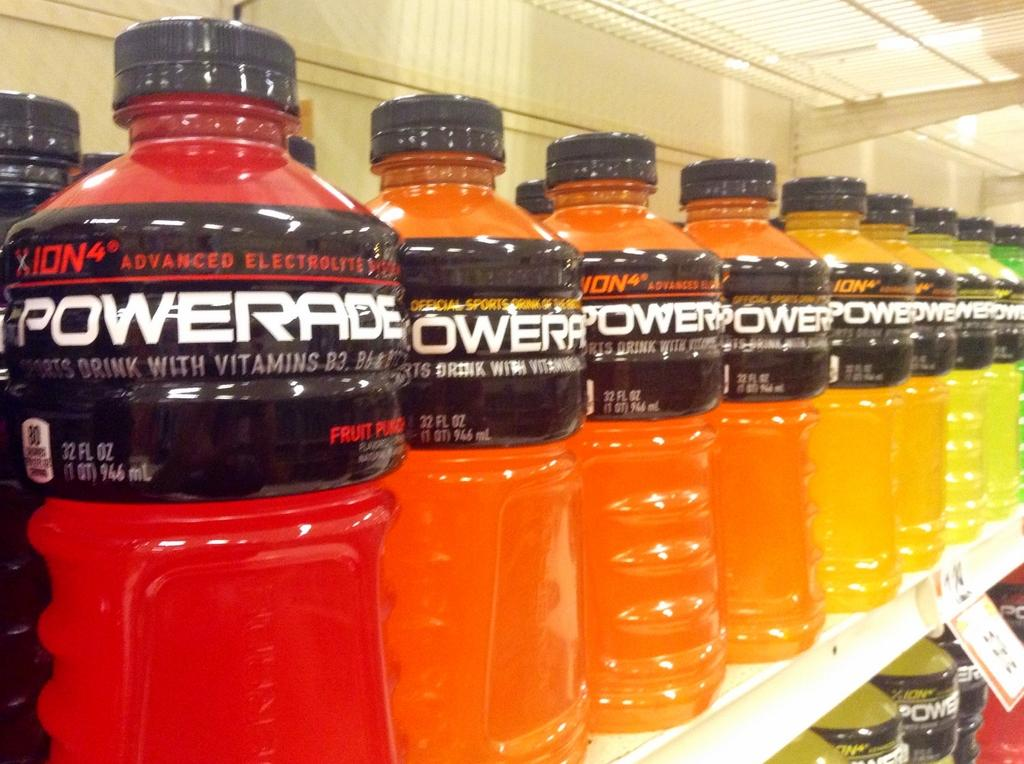<image>
Give a short and clear explanation of the subsequent image. Bottles of Powerade are organized to resemble the colors of a rainbow. 